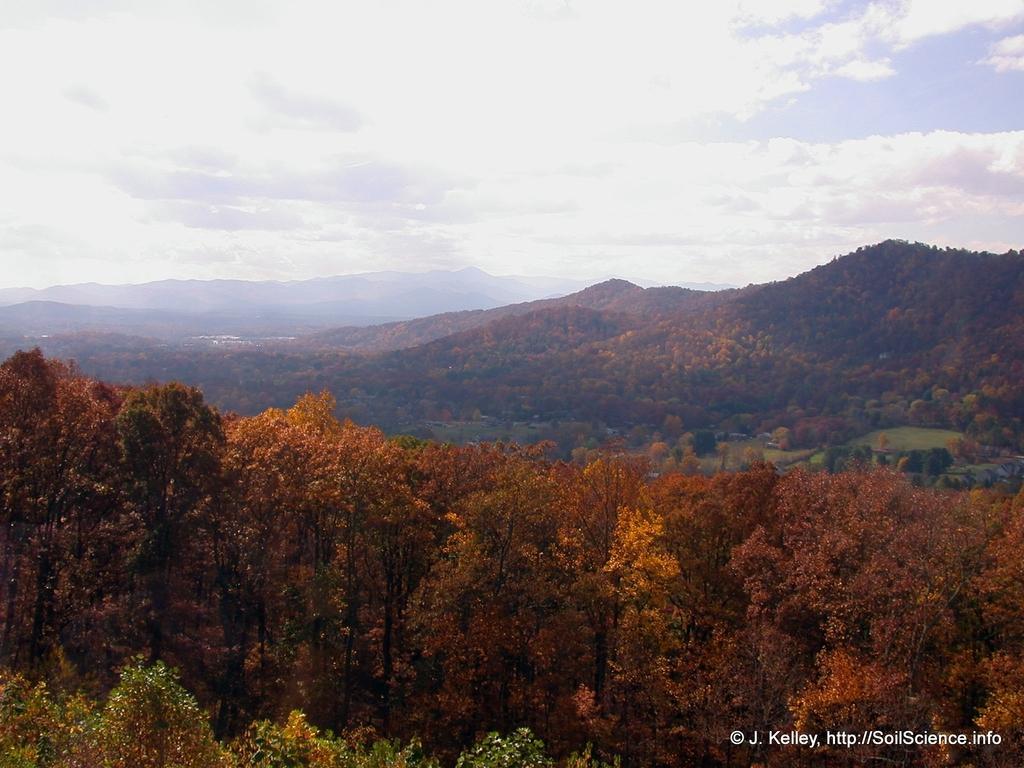Please provide a concise description of this image. In this image I can see trees. There are hills and in the background there is sky. Also in the bottom right corner of the image there is a watermark. 